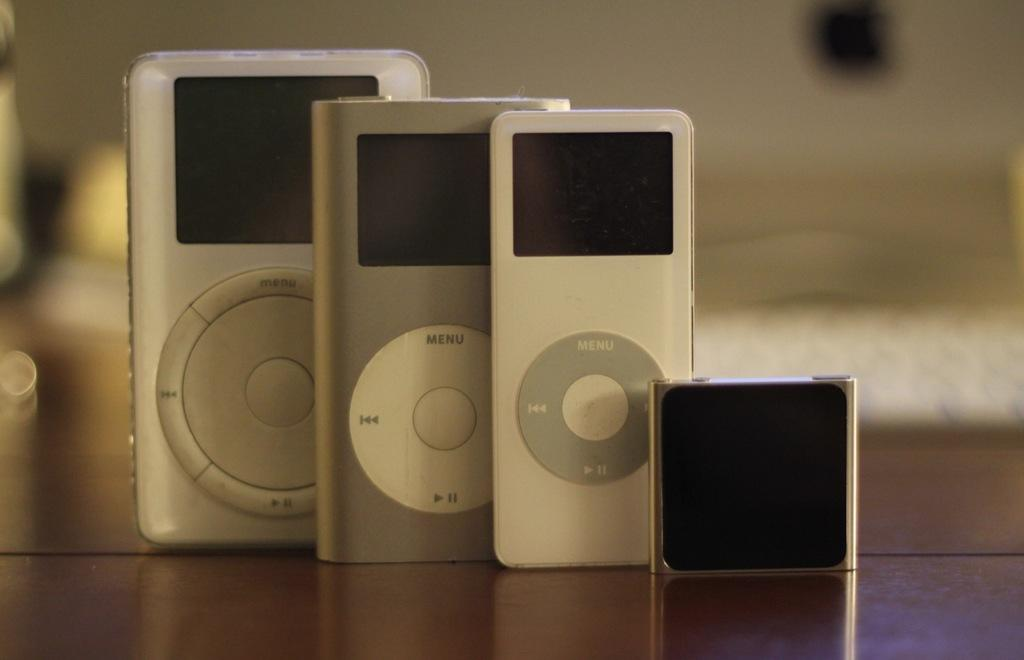What electronic devices can be seen on the table in the image? There are remotes and an iPod on the table in the image. What else can be seen in the background of the image? There are lights and a wall visible in the background. What type of knife is being used to cut the wall in the image? There is no knife present in the image, nor is anyone cutting the wall. 